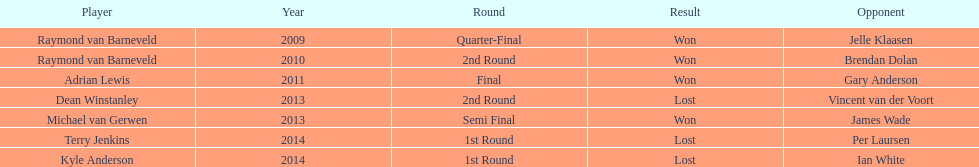Apart from kyle anderson, can you name others who suffered losses in the year 2014? Terry Jenkins. 